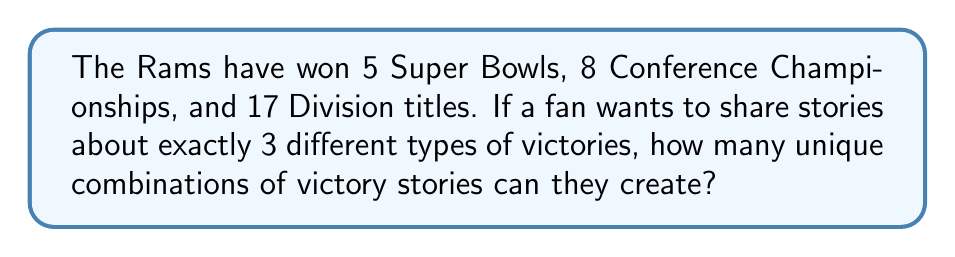Can you solve this math problem? Let's approach this step-by-step:

1) We have three types of victories:
   - Super Bowl wins (5)
   - Conference Championships (8)
   - Division titles (17)

2) We need to choose 3 different types of victories out of these 3 categories. This is equivalent to choosing all 3 categories, as we're told to share stories about exactly 3 different types of victories.

3) Now, for each category, we need to decide how many victories to talk about. We can use the stars and bars method to calculate this.

4) For Super Bowls:
   We need to choose between 0 to 5 Super Bowls.
   This is equivalent to putting 5 stars in 6 slots (including 0), which can be done in $\binom{5+1}{1} = 6$ ways.

5) For Conference Championships:
   We need to choose between 0 to 8 Championships.
   This is equivalent to putting 8 stars in 9 slots, which can be done in $\binom{8+1}{1} = 9$ ways.

6) For Division titles:
   We need to choose between 0 to 17 titles.
   This is equivalent to putting 17 stars in 18 slots, which can be done in $\binom{17+1}{1} = 18$ ways.

7) By the multiplication principle, the total number of unique combinations is:

   $$ 6 \times 9 \times 18 = 972 $$

Therefore, there are 972 unique combinations of victory stories that can be shared.
Answer: 972 